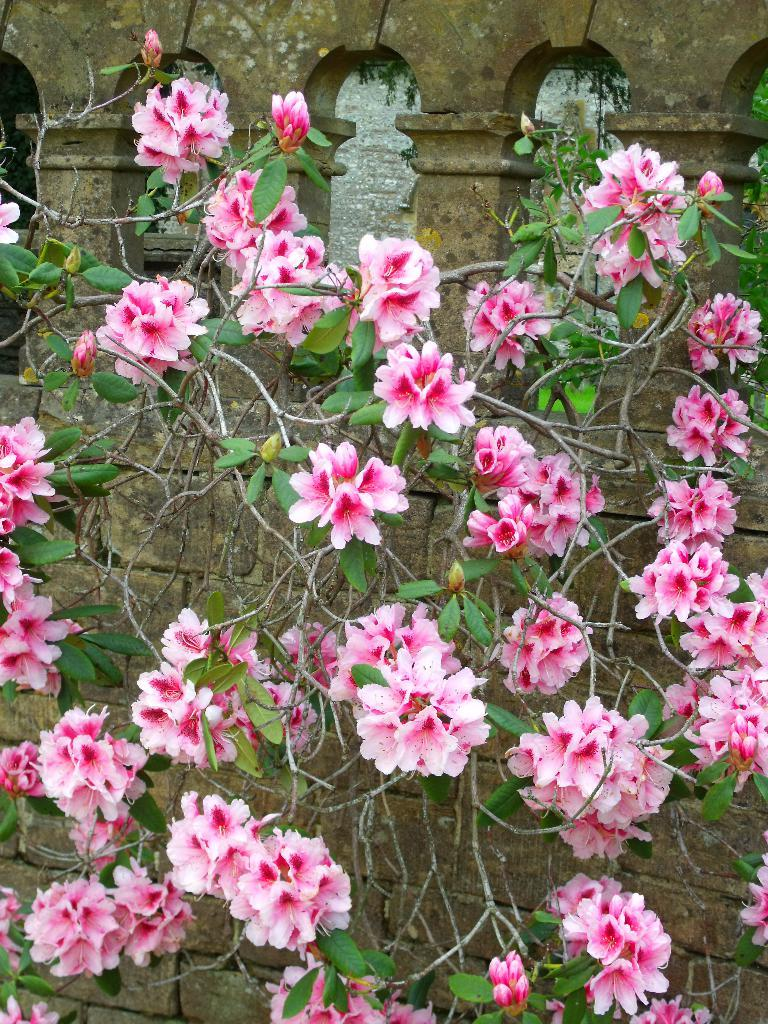What color are the flowers on the plant in the image? The flowers on the plant are pink. What can be seen behind the plant in the image? There is a wall visible at the back. How many pins are holding the flowers on the plant in the image? There is no mention of pins in the image, and the flowers appear to be naturally attached to the plant. 